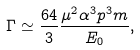<formula> <loc_0><loc_0><loc_500><loc_500>\Gamma \simeq \frac { 6 4 } { 3 } \frac { \mu ^ { 2 } \alpha ^ { 3 } p ^ { 3 } m } { E _ { 0 } } ,</formula> 